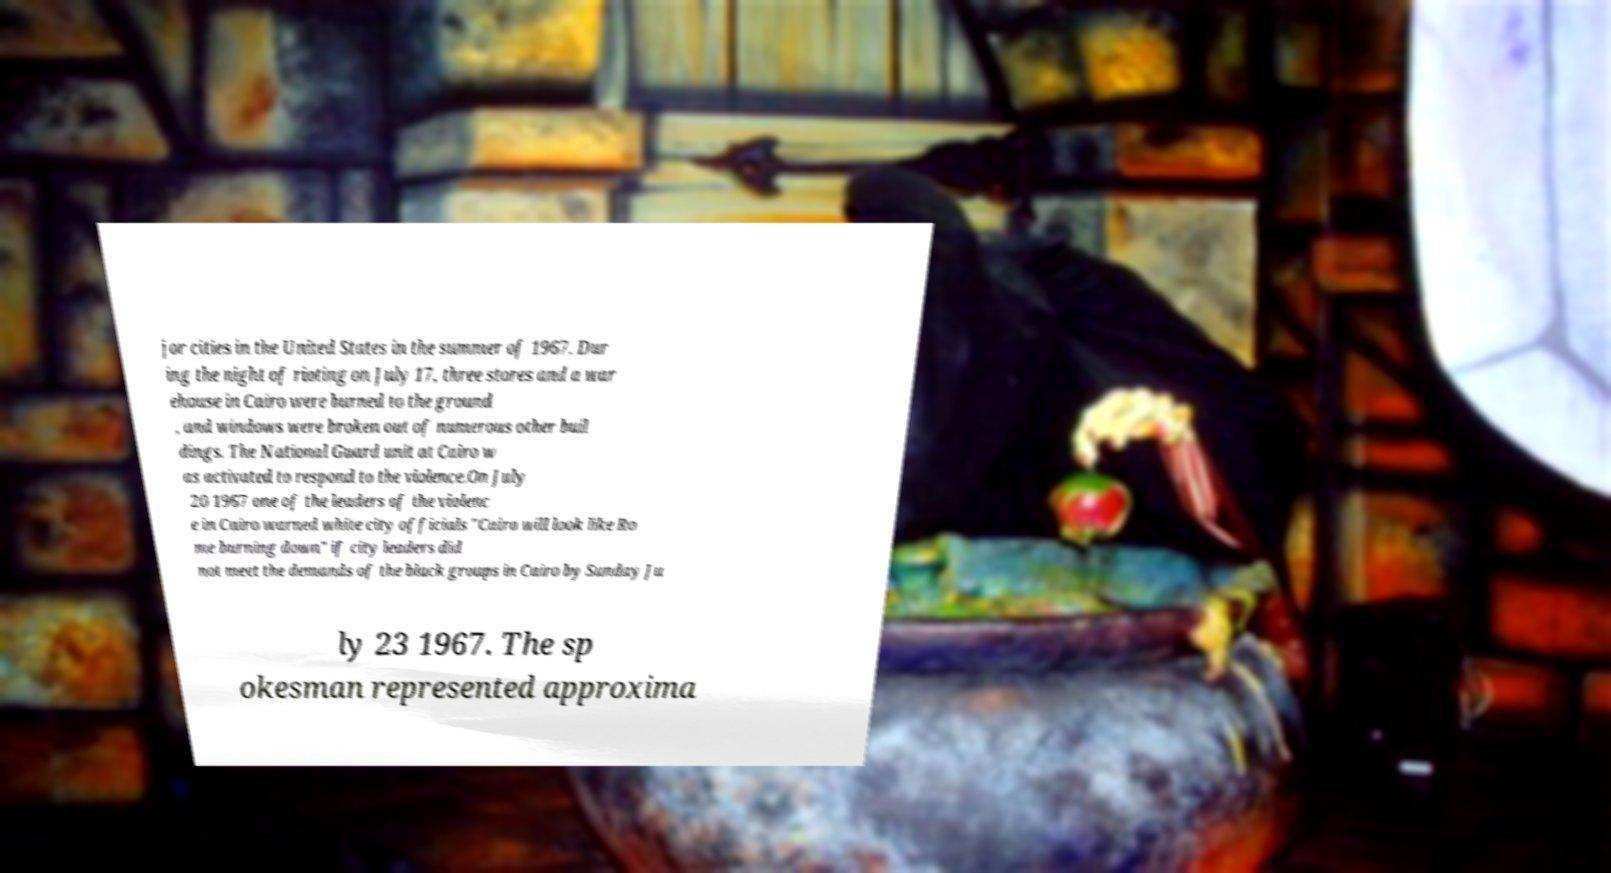I need the written content from this picture converted into text. Can you do that? jor cities in the United States in the summer of 1967. Dur ing the night of rioting on July 17, three stores and a war ehouse in Cairo were burned to the ground , and windows were broken out of numerous other buil dings. The National Guard unit at Cairo w as activated to respond to the violence.On July 20 1967 one of the leaders of the violenc e in Cairo warned white city officials "Cairo will look like Ro me burning down" if city leaders did not meet the demands of the black groups in Cairo by Sunday Ju ly 23 1967. The sp okesman represented approxima 